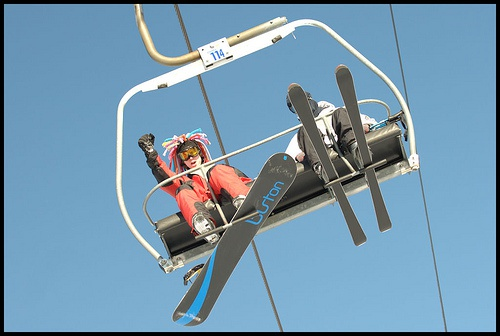Describe the objects in this image and their specific colors. I can see snowboard in black, gray, lightblue, and darkgray tones, people in black, salmon, and gray tones, skis in black, gray, and darkgray tones, and people in black, gray, white, and darkgray tones in this image. 